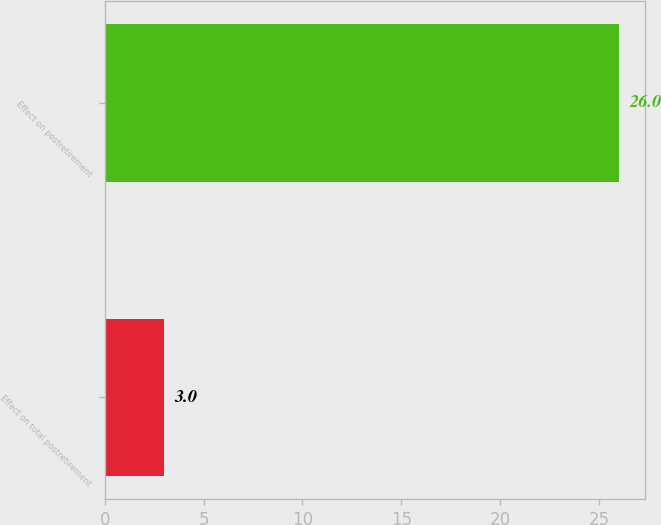Convert chart. <chart><loc_0><loc_0><loc_500><loc_500><bar_chart><fcel>Effect on total postretirement<fcel>Effect on postretirement<nl><fcel>3<fcel>26<nl></chart> 